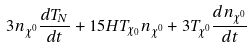Convert formula to latex. <formula><loc_0><loc_0><loc_500><loc_500>3 { n } _ { \chi ^ { 0 } } \frac { d { T } _ { N } } { d t } + 1 5 H { T } _ { \chi _ { 0 } } { n } _ { \chi ^ { 0 } } + 3 { T } _ { \chi ^ { 0 } } \frac { d { n } _ { \chi ^ { 0 } } } { d t }</formula> 